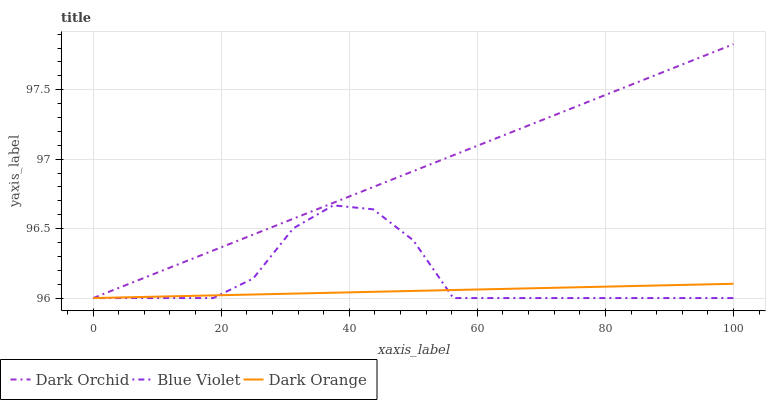Does Dark Orange have the minimum area under the curve?
Answer yes or no. Yes. Does Dark Orchid have the maximum area under the curve?
Answer yes or no. Yes. Does Blue Violet have the minimum area under the curve?
Answer yes or no. No. Does Blue Violet have the maximum area under the curve?
Answer yes or no. No. Is Dark Orange the smoothest?
Answer yes or no. Yes. Is Blue Violet the roughest?
Answer yes or no. Yes. Is Dark Orchid the smoothest?
Answer yes or no. No. Is Dark Orchid the roughest?
Answer yes or no. No. Does Dark Orange have the lowest value?
Answer yes or no. Yes. Does Dark Orchid have the highest value?
Answer yes or no. Yes. Does Blue Violet have the highest value?
Answer yes or no. No. Does Dark Orchid intersect Blue Violet?
Answer yes or no. Yes. Is Dark Orchid less than Blue Violet?
Answer yes or no. No. Is Dark Orchid greater than Blue Violet?
Answer yes or no. No. 